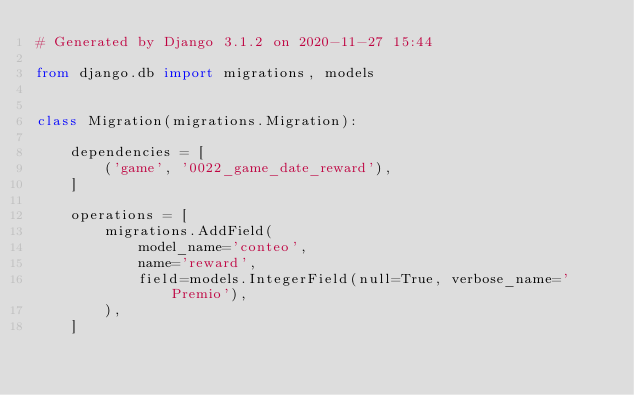Convert code to text. <code><loc_0><loc_0><loc_500><loc_500><_Python_># Generated by Django 3.1.2 on 2020-11-27 15:44

from django.db import migrations, models


class Migration(migrations.Migration):

    dependencies = [
        ('game', '0022_game_date_reward'),
    ]

    operations = [
        migrations.AddField(
            model_name='conteo',
            name='reward',
            field=models.IntegerField(null=True, verbose_name='Premio'),
        ),
    ]
</code> 